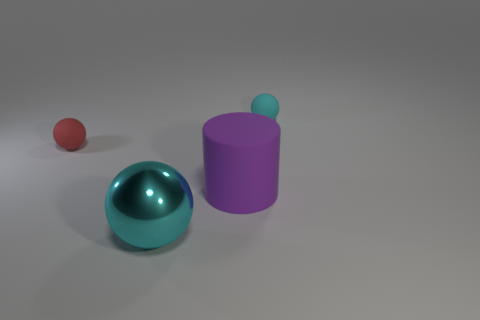Add 2 small shiny blocks. How many objects exist? 6 Subtract all balls. How many objects are left? 1 Subtract 1 red spheres. How many objects are left? 3 Subtract all blue metallic cylinders. Subtract all tiny red rubber things. How many objects are left? 3 Add 4 cyan rubber objects. How many cyan rubber objects are left? 5 Add 2 small rubber spheres. How many small rubber spheres exist? 4 